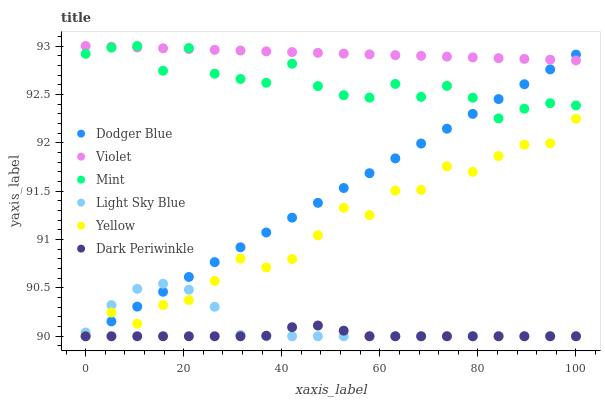Does Dark Periwinkle have the minimum area under the curve?
Answer yes or no. Yes. Does Violet have the maximum area under the curve?
Answer yes or no. Yes. Does Light Sky Blue have the minimum area under the curve?
Answer yes or no. No. Does Light Sky Blue have the maximum area under the curve?
Answer yes or no. No. Is Dodger Blue the smoothest?
Answer yes or no. Yes. Is Mint the roughest?
Answer yes or no. Yes. Is Light Sky Blue the smoothest?
Answer yes or no. No. Is Light Sky Blue the roughest?
Answer yes or no. No. Does Yellow have the lowest value?
Answer yes or no. Yes. Does Violet have the lowest value?
Answer yes or no. No. Does Mint have the highest value?
Answer yes or no. Yes. Does Light Sky Blue have the highest value?
Answer yes or no. No. Is Dark Periwinkle less than Mint?
Answer yes or no. Yes. Is Violet greater than Dark Periwinkle?
Answer yes or no. Yes. Does Violet intersect Mint?
Answer yes or no. Yes. Is Violet less than Mint?
Answer yes or no. No. Is Violet greater than Mint?
Answer yes or no. No. Does Dark Periwinkle intersect Mint?
Answer yes or no. No. 